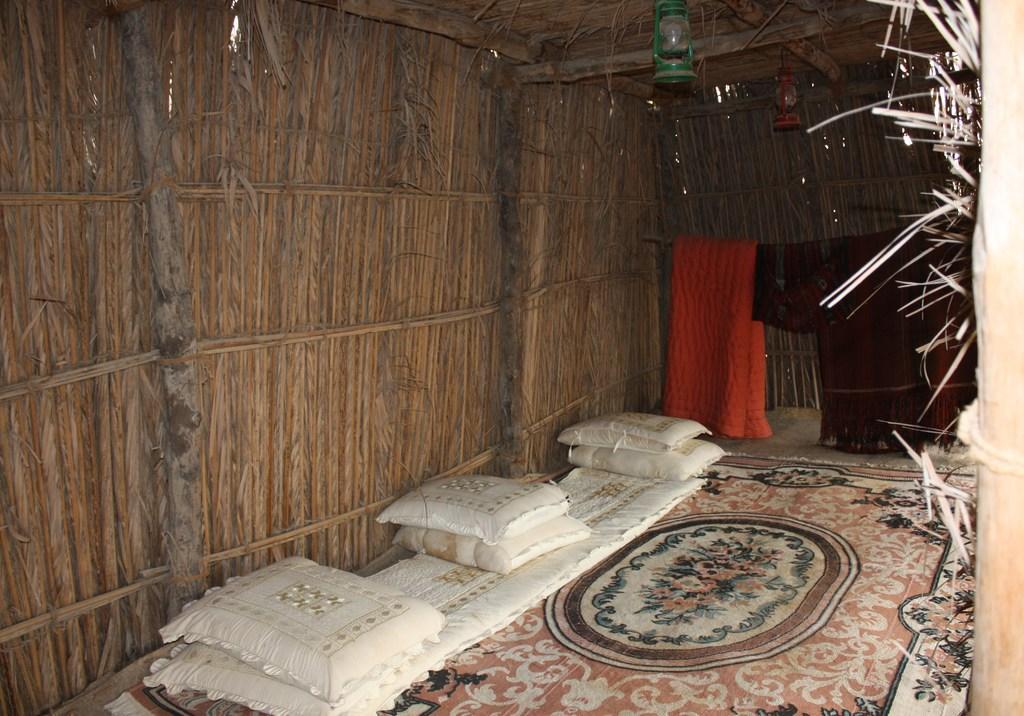How would you summarize this image in a sentence or two? This picture is an inside view of a hut. In the center of the image we can see the pillows, bed. On the right side of the image we can see the clothes, pole. At the top of the image we can see the roof and lamps. In the background of the image we can see the wood wall. 